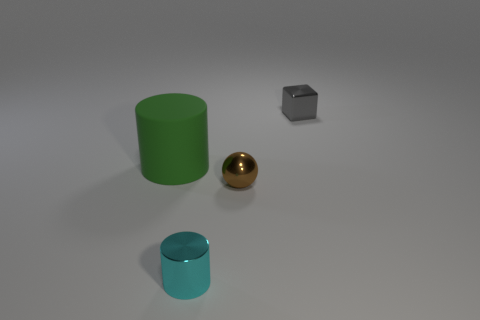What is the size of the block on the right side of the cylinder on the left side of the thing that is in front of the small sphere?
Your answer should be very brief. Small. Do the thing to the right of the brown ball and the green thing have the same material?
Your answer should be compact. No. Is there anything else that has the same shape as the small gray thing?
Keep it short and to the point. No. How many objects are either brown metallic spheres or tiny matte things?
Your response must be concise. 1. What is the size of the other rubber thing that is the same shape as the tiny cyan object?
Keep it short and to the point. Large. Are there any other things that have the same size as the green rubber cylinder?
Provide a succinct answer. No. What number of cylinders are cyan objects or green rubber objects?
Provide a succinct answer. 2. There is a cylinder left of the small metal object that is in front of the tiny ball; what color is it?
Offer a very short reply. Green. There is a tiny brown thing; what shape is it?
Offer a very short reply. Sphere. There is a thing behind the rubber cylinder; does it have the same size as the brown ball?
Provide a short and direct response. Yes. 